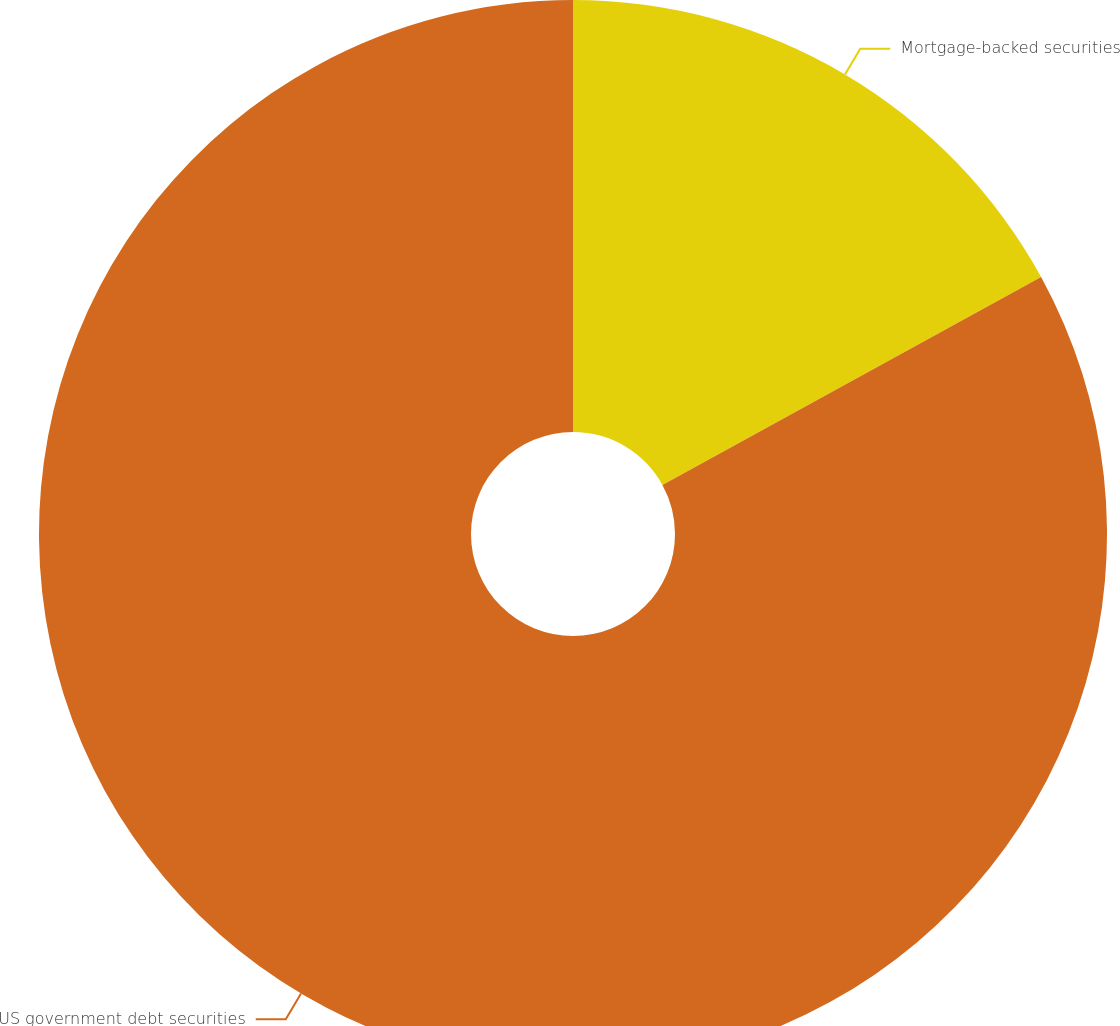Convert chart. <chart><loc_0><loc_0><loc_500><loc_500><pie_chart><fcel>Mortgage-backed securities<fcel>US government debt securities<nl><fcel>17.01%<fcel>82.99%<nl></chart> 